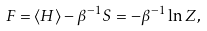<formula> <loc_0><loc_0><loc_500><loc_500>F = \langle H \rangle - \beta ^ { - 1 } S = - \beta ^ { - 1 } \ln Z ,</formula> 